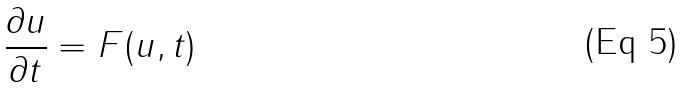<formula> <loc_0><loc_0><loc_500><loc_500>\frac { \partial u } { \partial t } = F ( u , t )</formula> 